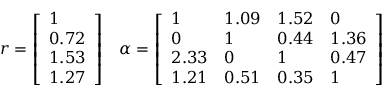Convert formula to latex. <formula><loc_0><loc_0><loc_500><loc_500>r = { \left [ \begin{array} { l } { 1 } \\ { 0 . 7 2 } \\ { 1 . 5 3 } \\ { 1 . 2 7 } \end{array} \right ] } \quad \alpha = { \left [ \begin{array} { l l l l } { 1 } & { 1 . 0 9 } & { 1 . 5 2 } & { 0 } \\ { 0 } & { 1 } & { 0 . 4 4 } & { 1 . 3 6 } \\ { 2 . 3 3 } & { 0 } & { 1 } & { 0 . 4 7 } \\ { 1 . 2 1 } & { 0 . 5 1 } & { 0 . 3 5 } & { 1 } \end{array} \right ] }</formula> 